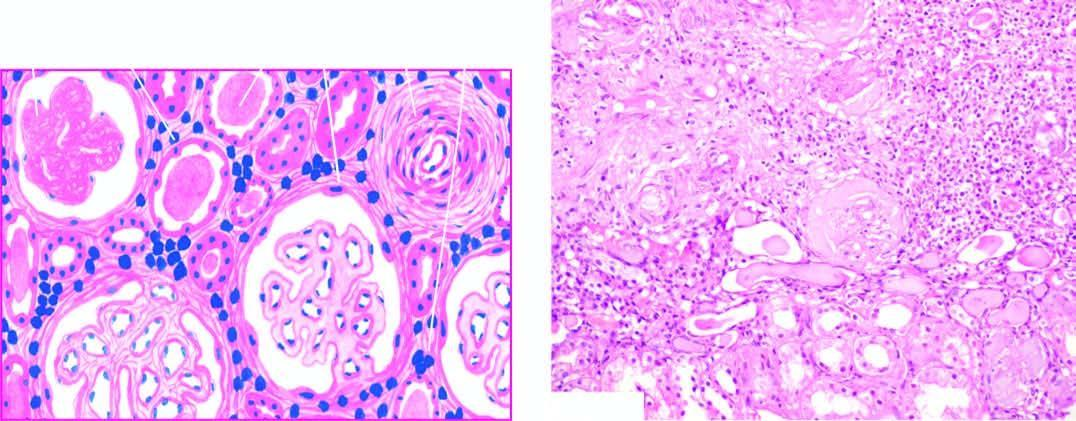does the wedge-shaped infarct show atrophy of some tubules and dilatation of others which contain colloid casts thyroidisation?
Answer the question using a single word or phrase. No 